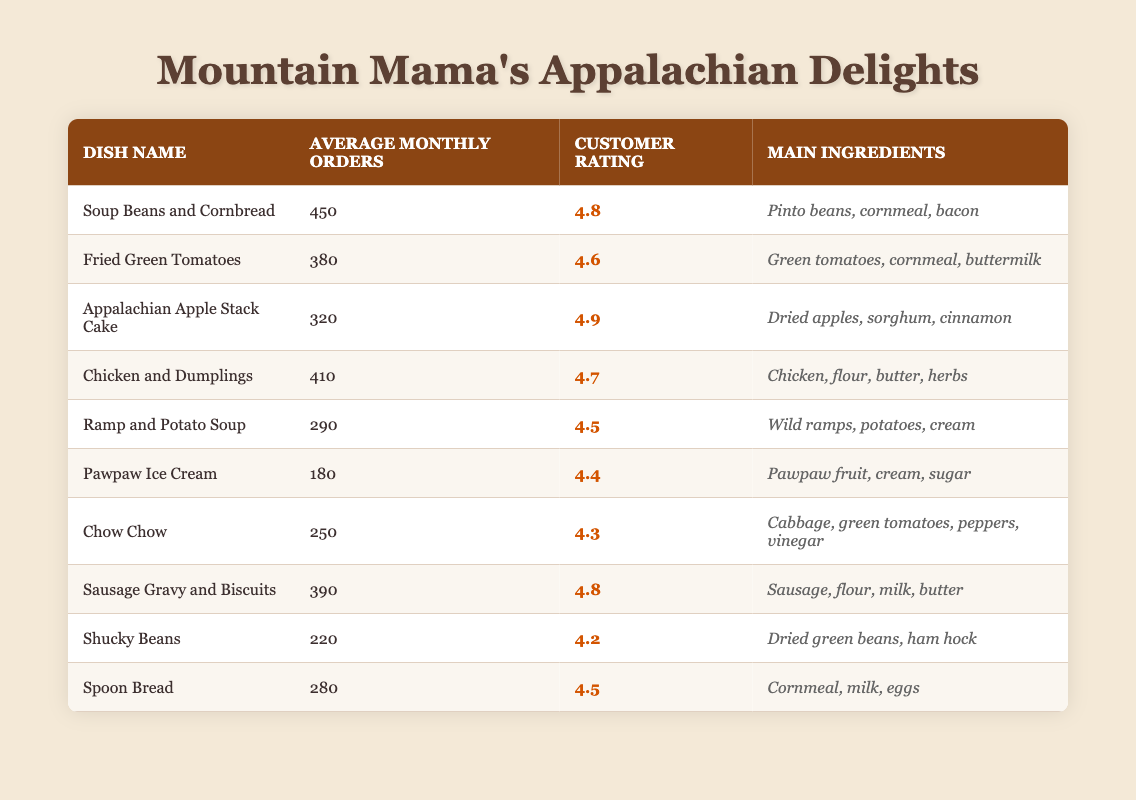What is the dish with the highest average monthly orders? By scanning the "Average Monthly Orders" column, I find that "Soup Beans and Cornbread" has the highest value at 450.
Answer: Soup Beans and Cornbread How many dishes have a customer rating of 4.5 or higher? Counting from the "Customer Rating" column, there are six dishes with ratings of 4.5 or higher: Soup Beans and Cornbread, Fried Green Tomatoes, Appalachian Apple Stack Cake, Chicken and Dumplings, Sausage Gravy and Biscuits, and Spoon Bread.
Answer: 6 What are the main ingredients of the dish with the lowest customer rating? Looking at the "Customer Rating" column, "Shucky Beans" has the lowest rating at 4.2. The "Main Ingredients" for this dish are dried green beans and ham hock.
Answer: Dried green beans, ham hock What is the average number of orders for all the dishes? To find the average, first, I sum the values in the "Average Monthly Orders" column: 450 + 380 + 320 + 410 + 290 + 180 + 250 + 390 + 220 + 280 = 2870. Then, divide by the number of dishes (10): 2870 / 10 = 287.
Answer: 287 Is "Pawpaw Ice Cream" ordered more frequently than "Chow Chow"? Comparing the "Average Monthly Orders", Pawpaw Ice Cream has 180 while Chow Chow has 250, therefore, "Pawpaw Ice Cream" is not ordered more frequently than "Chow Chow".
Answer: No What is the difference between the average monthly orders of "Ramp and Potato Soup" and "Fried Green Tomatoes"? "Ramp and Potato Soup" has 290 average monthly orders and "Fried Green Tomatoes" has 380. The difference is 380 - 290 = 90.
Answer: 90 Which dish's main ingredients include cornmeal and also has a customer rating above 4.5? The dishes that include cornmeal and have a customer rating above 4.5 are "Fried Green Tomatoes", "Spoon Bread", and "Soup Beans and Cornbread".
Answer: Fried Green Tomatoes, Spoon Bread, Soup Beans and Cornbread How many dishes use bacon as an ingredient? By reviewing the "Main Ingredients" column, only "Soup Beans and Cornbread" is noted to include bacon as an ingredient.
Answer: 1 